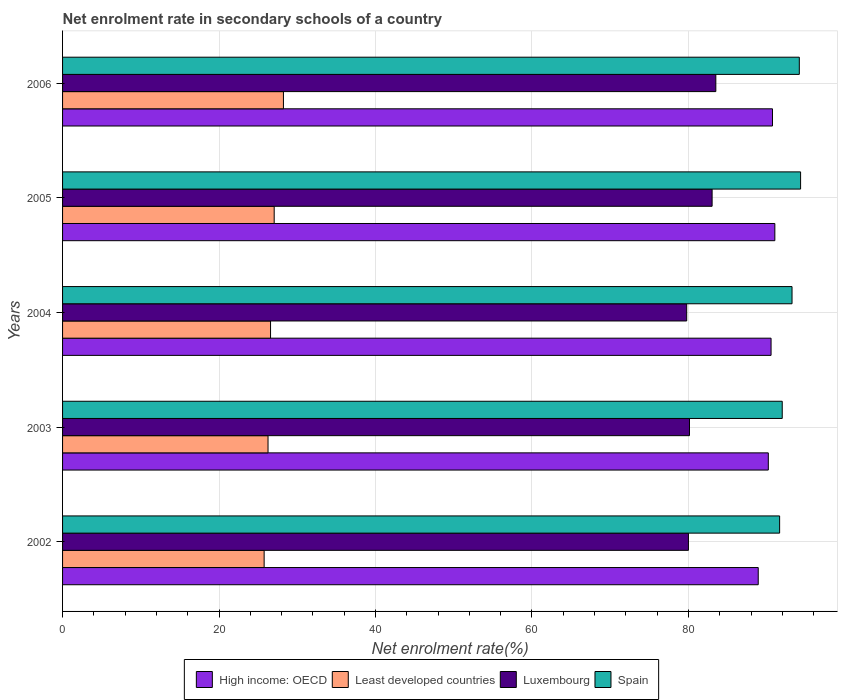How many different coloured bars are there?
Your response must be concise. 4. In how many cases, is the number of bars for a given year not equal to the number of legend labels?
Offer a very short reply. 0. What is the net enrolment rate in secondary schools in Least developed countries in 2006?
Offer a very short reply. 28.23. Across all years, what is the maximum net enrolment rate in secondary schools in Spain?
Offer a very short reply. 94.33. Across all years, what is the minimum net enrolment rate in secondary schools in Least developed countries?
Your response must be concise. 25.77. In which year was the net enrolment rate in secondary schools in Spain maximum?
Offer a terse response. 2005. What is the total net enrolment rate in secondary schools in Spain in the graph?
Your response must be concise. 465.39. What is the difference between the net enrolment rate in secondary schools in Luxembourg in 2002 and that in 2004?
Offer a terse response. 0.22. What is the difference between the net enrolment rate in secondary schools in High income: OECD in 2006 and the net enrolment rate in secondary schools in Spain in 2003?
Offer a very short reply. -1.24. What is the average net enrolment rate in secondary schools in Least developed countries per year?
Offer a terse response. 26.78. In the year 2004, what is the difference between the net enrolment rate in secondary schools in Spain and net enrolment rate in secondary schools in Luxembourg?
Ensure brevity in your answer.  13.46. What is the ratio of the net enrolment rate in secondary schools in Least developed countries in 2002 to that in 2006?
Offer a terse response. 0.91. Is the net enrolment rate in secondary schools in Luxembourg in 2003 less than that in 2005?
Your response must be concise. Yes. Is the difference between the net enrolment rate in secondary schools in Spain in 2002 and 2005 greater than the difference between the net enrolment rate in secondary schools in Luxembourg in 2002 and 2005?
Offer a terse response. Yes. What is the difference between the highest and the second highest net enrolment rate in secondary schools in Least developed countries?
Keep it short and to the point. 1.18. What is the difference between the highest and the lowest net enrolment rate in secondary schools in High income: OECD?
Provide a short and direct response. 2.12. What does the 2nd bar from the top in 2002 represents?
Give a very brief answer. Luxembourg. What does the 2nd bar from the bottom in 2005 represents?
Offer a terse response. Least developed countries. What is the difference between two consecutive major ticks on the X-axis?
Your answer should be compact. 20. Are the values on the major ticks of X-axis written in scientific E-notation?
Keep it short and to the point. No. Does the graph contain grids?
Your answer should be compact. Yes. How are the legend labels stacked?
Provide a short and direct response. Horizontal. What is the title of the graph?
Keep it short and to the point. Net enrolment rate in secondary schools of a country. What is the label or title of the X-axis?
Your answer should be very brief. Net enrolment rate(%). What is the Net enrolment rate(%) of High income: OECD in 2002?
Provide a short and direct response. 88.92. What is the Net enrolment rate(%) in Least developed countries in 2002?
Provide a short and direct response. 25.77. What is the Net enrolment rate(%) in Luxembourg in 2002?
Give a very brief answer. 80. What is the Net enrolment rate(%) of Spain in 2002?
Ensure brevity in your answer.  91.65. What is the Net enrolment rate(%) in High income: OECD in 2003?
Provide a succinct answer. 90.21. What is the Net enrolment rate(%) in Least developed countries in 2003?
Offer a terse response. 26.26. What is the Net enrolment rate(%) in Luxembourg in 2003?
Provide a succinct answer. 80.13. What is the Net enrolment rate(%) in Spain in 2003?
Provide a short and direct response. 91.99. What is the Net enrolment rate(%) of High income: OECD in 2004?
Your answer should be very brief. 90.56. What is the Net enrolment rate(%) in Least developed countries in 2004?
Your answer should be very brief. 26.58. What is the Net enrolment rate(%) of Luxembourg in 2004?
Offer a very short reply. 79.78. What is the Net enrolment rate(%) in Spain in 2004?
Make the answer very short. 93.24. What is the Net enrolment rate(%) in High income: OECD in 2005?
Offer a very short reply. 91.04. What is the Net enrolment rate(%) of Least developed countries in 2005?
Give a very brief answer. 27.05. What is the Net enrolment rate(%) in Luxembourg in 2005?
Provide a succinct answer. 83.03. What is the Net enrolment rate(%) of Spain in 2005?
Your answer should be compact. 94.33. What is the Net enrolment rate(%) in High income: OECD in 2006?
Ensure brevity in your answer.  90.74. What is the Net enrolment rate(%) in Least developed countries in 2006?
Your answer should be compact. 28.23. What is the Net enrolment rate(%) in Luxembourg in 2006?
Your answer should be very brief. 83.5. What is the Net enrolment rate(%) of Spain in 2006?
Ensure brevity in your answer.  94.17. Across all years, what is the maximum Net enrolment rate(%) of High income: OECD?
Offer a very short reply. 91.04. Across all years, what is the maximum Net enrolment rate(%) in Least developed countries?
Make the answer very short. 28.23. Across all years, what is the maximum Net enrolment rate(%) of Luxembourg?
Your answer should be very brief. 83.5. Across all years, what is the maximum Net enrolment rate(%) in Spain?
Provide a short and direct response. 94.33. Across all years, what is the minimum Net enrolment rate(%) of High income: OECD?
Give a very brief answer. 88.92. Across all years, what is the minimum Net enrolment rate(%) in Least developed countries?
Give a very brief answer. 25.77. Across all years, what is the minimum Net enrolment rate(%) of Luxembourg?
Keep it short and to the point. 79.78. Across all years, what is the minimum Net enrolment rate(%) in Spain?
Give a very brief answer. 91.65. What is the total Net enrolment rate(%) in High income: OECD in the graph?
Your answer should be very brief. 451.48. What is the total Net enrolment rate(%) of Least developed countries in the graph?
Your answer should be compact. 133.89. What is the total Net enrolment rate(%) of Luxembourg in the graph?
Offer a very short reply. 406.44. What is the total Net enrolment rate(%) of Spain in the graph?
Your answer should be compact. 465.39. What is the difference between the Net enrolment rate(%) in High income: OECD in 2002 and that in 2003?
Your response must be concise. -1.29. What is the difference between the Net enrolment rate(%) of Least developed countries in 2002 and that in 2003?
Your answer should be compact. -0.5. What is the difference between the Net enrolment rate(%) in Luxembourg in 2002 and that in 2003?
Ensure brevity in your answer.  -0.14. What is the difference between the Net enrolment rate(%) of Spain in 2002 and that in 2003?
Make the answer very short. -0.33. What is the difference between the Net enrolment rate(%) of High income: OECD in 2002 and that in 2004?
Offer a terse response. -1.64. What is the difference between the Net enrolment rate(%) of Least developed countries in 2002 and that in 2004?
Your response must be concise. -0.82. What is the difference between the Net enrolment rate(%) in Luxembourg in 2002 and that in 2004?
Offer a terse response. 0.22. What is the difference between the Net enrolment rate(%) of Spain in 2002 and that in 2004?
Your answer should be compact. -1.59. What is the difference between the Net enrolment rate(%) in High income: OECD in 2002 and that in 2005?
Your answer should be very brief. -2.12. What is the difference between the Net enrolment rate(%) in Least developed countries in 2002 and that in 2005?
Make the answer very short. -1.28. What is the difference between the Net enrolment rate(%) in Luxembourg in 2002 and that in 2005?
Your response must be concise. -3.03. What is the difference between the Net enrolment rate(%) in Spain in 2002 and that in 2005?
Provide a short and direct response. -2.68. What is the difference between the Net enrolment rate(%) of High income: OECD in 2002 and that in 2006?
Give a very brief answer. -1.82. What is the difference between the Net enrolment rate(%) of Least developed countries in 2002 and that in 2006?
Offer a very short reply. -2.47. What is the difference between the Net enrolment rate(%) in Luxembourg in 2002 and that in 2006?
Offer a very short reply. -3.5. What is the difference between the Net enrolment rate(%) in Spain in 2002 and that in 2006?
Provide a succinct answer. -2.52. What is the difference between the Net enrolment rate(%) of High income: OECD in 2003 and that in 2004?
Offer a very short reply. -0.35. What is the difference between the Net enrolment rate(%) of Least developed countries in 2003 and that in 2004?
Make the answer very short. -0.32. What is the difference between the Net enrolment rate(%) of Luxembourg in 2003 and that in 2004?
Ensure brevity in your answer.  0.36. What is the difference between the Net enrolment rate(%) of Spain in 2003 and that in 2004?
Provide a short and direct response. -1.25. What is the difference between the Net enrolment rate(%) of High income: OECD in 2003 and that in 2005?
Offer a very short reply. -0.83. What is the difference between the Net enrolment rate(%) of Least developed countries in 2003 and that in 2005?
Your answer should be very brief. -0.79. What is the difference between the Net enrolment rate(%) in Luxembourg in 2003 and that in 2005?
Provide a succinct answer. -2.89. What is the difference between the Net enrolment rate(%) of Spain in 2003 and that in 2005?
Offer a very short reply. -2.35. What is the difference between the Net enrolment rate(%) of High income: OECD in 2003 and that in 2006?
Your answer should be compact. -0.53. What is the difference between the Net enrolment rate(%) of Least developed countries in 2003 and that in 2006?
Make the answer very short. -1.97. What is the difference between the Net enrolment rate(%) in Luxembourg in 2003 and that in 2006?
Give a very brief answer. -3.37. What is the difference between the Net enrolment rate(%) of Spain in 2003 and that in 2006?
Your answer should be compact. -2.18. What is the difference between the Net enrolment rate(%) of High income: OECD in 2004 and that in 2005?
Provide a succinct answer. -0.48. What is the difference between the Net enrolment rate(%) of Least developed countries in 2004 and that in 2005?
Your response must be concise. -0.46. What is the difference between the Net enrolment rate(%) in Luxembourg in 2004 and that in 2005?
Make the answer very short. -3.25. What is the difference between the Net enrolment rate(%) of Spain in 2004 and that in 2005?
Keep it short and to the point. -1.09. What is the difference between the Net enrolment rate(%) in High income: OECD in 2004 and that in 2006?
Offer a very short reply. -0.18. What is the difference between the Net enrolment rate(%) in Least developed countries in 2004 and that in 2006?
Your answer should be compact. -1.65. What is the difference between the Net enrolment rate(%) of Luxembourg in 2004 and that in 2006?
Your answer should be compact. -3.72. What is the difference between the Net enrolment rate(%) in Spain in 2004 and that in 2006?
Provide a short and direct response. -0.93. What is the difference between the Net enrolment rate(%) in High income: OECD in 2005 and that in 2006?
Offer a very short reply. 0.3. What is the difference between the Net enrolment rate(%) in Least developed countries in 2005 and that in 2006?
Make the answer very short. -1.18. What is the difference between the Net enrolment rate(%) of Luxembourg in 2005 and that in 2006?
Give a very brief answer. -0.47. What is the difference between the Net enrolment rate(%) of Spain in 2005 and that in 2006?
Ensure brevity in your answer.  0.16. What is the difference between the Net enrolment rate(%) in High income: OECD in 2002 and the Net enrolment rate(%) in Least developed countries in 2003?
Your answer should be compact. 62.66. What is the difference between the Net enrolment rate(%) of High income: OECD in 2002 and the Net enrolment rate(%) of Luxembourg in 2003?
Give a very brief answer. 8.79. What is the difference between the Net enrolment rate(%) of High income: OECD in 2002 and the Net enrolment rate(%) of Spain in 2003?
Your response must be concise. -3.07. What is the difference between the Net enrolment rate(%) in Least developed countries in 2002 and the Net enrolment rate(%) in Luxembourg in 2003?
Give a very brief answer. -54.37. What is the difference between the Net enrolment rate(%) of Least developed countries in 2002 and the Net enrolment rate(%) of Spain in 2003?
Make the answer very short. -66.22. What is the difference between the Net enrolment rate(%) in Luxembourg in 2002 and the Net enrolment rate(%) in Spain in 2003?
Keep it short and to the point. -11.99. What is the difference between the Net enrolment rate(%) in High income: OECD in 2002 and the Net enrolment rate(%) in Least developed countries in 2004?
Keep it short and to the point. 62.34. What is the difference between the Net enrolment rate(%) in High income: OECD in 2002 and the Net enrolment rate(%) in Luxembourg in 2004?
Offer a terse response. 9.14. What is the difference between the Net enrolment rate(%) in High income: OECD in 2002 and the Net enrolment rate(%) in Spain in 2004?
Your answer should be very brief. -4.32. What is the difference between the Net enrolment rate(%) of Least developed countries in 2002 and the Net enrolment rate(%) of Luxembourg in 2004?
Offer a terse response. -54.01. What is the difference between the Net enrolment rate(%) of Least developed countries in 2002 and the Net enrolment rate(%) of Spain in 2004?
Your answer should be compact. -67.48. What is the difference between the Net enrolment rate(%) in Luxembourg in 2002 and the Net enrolment rate(%) in Spain in 2004?
Provide a short and direct response. -13.24. What is the difference between the Net enrolment rate(%) of High income: OECD in 2002 and the Net enrolment rate(%) of Least developed countries in 2005?
Make the answer very short. 61.87. What is the difference between the Net enrolment rate(%) in High income: OECD in 2002 and the Net enrolment rate(%) in Luxembourg in 2005?
Provide a succinct answer. 5.9. What is the difference between the Net enrolment rate(%) of High income: OECD in 2002 and the Net enrolment rate(%) of Spain in 2005?
Your response must be concise. -5.41. What is the difference between the Net enrolment rate(%) of Least developed countries in 2002 and the Net enrolment rate(%) of Luxembourg in 2005?
Provide a short and direct response. -57.26. What is the difference between the Net enrolment rate(%) of Least developed countries in 2002 and the Net enrolment rate(%) of Spain in 2005?
Provide a succinct answer. -68.57. What is the difference between the Net enrolment rate(%) of Luxembourg in 2002 and the Net enrolment rate(%) of Spain in 2005?
Your response must be concise. -14.34. What is the difference between the Net enrolment rate(%) in High income: OECD in 2002 and the Net enrolment rate(%) in Least developed countries in 2006?
Provide a short and direct response. 60.69. What is the difference between the Net enrolment rate(%) in High income: OECD in 2002 and the Net enrolment rate(%) in Luxembourg in 2006?
Your answer should be compact. 5.42. What is the difference between the Net enrolment rate(%) in High income: OECD in 2002 and the Net enrolment rate(%) in Spain in 2006?
Provide a short and direct response. -5.25. What is the difference between the Net enrolment rate(%) in Least developed countries in 2002 and the Net enrolment rate(%) in Luxembourg in 2006?
Your response must be concise. -57.73. What is the difference between the Net enrolment rate(%) in Least developed countries in 2002 and the Net enrolment rate(%) in Spain in 2006?
Give a very brief answer. -68.41. What is the difference between the Net enrolment rate(%) in Luxembourg in 2002 and the Net enrolment rate(%) in Spain in 2006?
Offer a very short reply. -14.17. What is the difference between the Net enrolment rate(%) of High income: OECD in 2003 and the Net enrolment rate(%) of Least developed countries in 2004?
Your answer should be compact. 63.63. What is the difference between the Net enrolment rate(%) in High income: OECD in 2003 and the Net enrolment rate(%) in Luxembourg in 2004?
Keep it short and to the point. 10.43. What is the difference between the Net enrolment rate(%) in High income: OECD in 2003 and the Net enrolment rate(%) in Spain in 2004?
Your answer should be very brief. -3.03. What is the difference between the Net enrolment rate(%) in Least developed countries in 2003 and the Net enrolment rate(%) in Luxembourg in 2004?
Provide a short and direct response. -53.52. What is the difference between the Net enrolment rate(%) of Least developed countries in 2003 and the Net enrolment rate(%) of Spain in 2004?
Your answer should be very brief. -66.98. What is the difference between the Net enrolment rate(%) in Luxembourg in 2003 and the Net enrolment rate(%) in Spain in 2004?
Offer a terse response. -13.11. What is the difference between the Net enrolment rate(%) in High income: OECD in 2003 and the Net enrolment rate(%) in Least developed countries in 2005?
Give a very brief answer. 63.16. What is the difference between the Net enrolment rate(%) in High income: OECD in 2003 and the Net enrolment rate(%) in Luxembourg in 2005?
Ensure brevity in your answer.  7.18. What is the difference between the Net enrolment rate(%) of High income: OECD in 2003 and the Net enrolment rate(%) of Spain in 2005?
Offer a very short reply. -4.13. What is the difference between the Net enrolment rate(%) in Least developed countries in 2003 and the Net enrolment rate(%) in Luxembourg in 2005?
Your answer should be compact. -56.76. What is the difference between the Net enrolment rate(%) of Least developed countries in 2003 and the Net enrolment rate(%) of Spain in 2005?
Your answer should be very brief. -68.07. What is the difference between the Net enrolment rate(%) in Luxembourg in 2003 and the Net enrolment rate(%) in Spain in 2005?
Your answer should be very brief. -14.2. What is the difference between the Net enrolment rate(%) of High income: OECD in 2003 and the Net enrolment rate(%) of Least developed countries in 2006?
Make the answer very short. 61.98. What is the difference between the Net enrolment rate(%) in High income: OECD in 2003 and the Net enrolment rate(%) in Luxembourg in 2006?
Your answer should be very brief. 6.71. What is the difference between the Net enrolment rate(%) in High income: OECD in 2003 and the Net enrolment rate(%) in Spain in 2006?
Provide a succinct answer. -3.96. What is the difference between the Net enrolment rate(%) in Least developed countries in 2003 and the Net enrolment rate(%) in Luxembourg in 2006?
Your response must be concise. -57.24. What is the difference between the Net enrolment rate(%) in Least developed countries in 2003 and the Net enrolment rate(%) in Spain in 2006?
Your response must be concise. -67.91. What is the difference between the Net enrolment rate(%) in Luxembourg in 2003 and the Net enrolment rate(%) in Spain in 2006?
Offer a very short reply. -14.04. What is the difference between the Net enrolment rate(%) of High income: OECD in 2004 and the Net enrolment rate(%) of Least developed countries in 2005?
Provide a short and direct response. 63.51. What is the difference between the Net enrolment rate(%) in High income: OECD in 2004 and the Net enrolment rate(%) in Luxembourg in 2005?
Offer a very short reply. 7.54. What is the difference between the Net enrolment rate(%) in High income: OECD in 2004 and the Net enrolment rate(%) in Spain in 2005?
Make the answer very short. -3.77. What is the difference between the Net enrolment rate(%) of Least developed countries in 2004 and the Net enrolment rate(%) of Luxembourg in 2005?
Keep it short and to the point. -56.44. What is the difference between the Net enrolment rate(%) in Least developed countries in 2004 and the Net enrolment rate(%) in Spain in 2005?
Your response must be concise. -67.75. What is the difference between the Net enrolment rate(%) of Luxembourg in 2004 and the Net enrolment rate(%) of Spain in 2005?
Give a very brief answer. -14.56. What is the difference between the Net enrolment rate(%) of High income: OECD in 2004 and the Net enrolment rate(%) of Least developed countries in 2006?
Your answer should be compact. 62.33. What is the difference between the Net enrolment rate(%) in High income: OECD in 2004 and the Net enrolment rate(%) in Luxembourg in 2006?
Your answer should be compact. 7.06. What is the difference between the Net enrolment rate(%) in High income: OECD in 2004 and the Net enrolment rate(%) in Spain in 2006?
Your answer should be compact. -3.61. What is the difference between the Net enrolment rate(%) of Least developed countries in 2004 and the Net enrolment rate(%) of Luxembourg in 2006?
Offer a terse response. -56.92. What is the difference between the Net enrolment rate(%) in Least developed countries in 2004 and the Net enrolment rate(%) in Spain in 2006?
Provide a succinct answer. -67.59. What is the difference between the Net enrolment rate(%) in Luxembourg in 2004 and the Net enrolment rate(%) in Spain in 2006?
Ensure brevity in your answer.  -14.39. What is the difference between the Net enrolment rate(%) of High income: OECD in 2005 and the Net enrolment rate(%) of Least developed countries in 2006?
Give a very brief answer. 62.81. What is the difference between the Net enrolment rate(%) of High income: OECD in 2005 and the Net enrolment rate(%) of Luxembourg in 2006?
Keep it short and to the point. 7.54. What is the difference between the Net enrolment rate(%) in High income: OECD in 2005 and the Net enrolment rate(%) in Spain in 2006?
Keep it short and to the point. -3.13. What is the difference between the Net enrolment rate(%) in Least developed countries in 2005 and the Net enrolment rate(%) in Luxembourg in 2006?
Keep it short and to the point. -56.45. What is the difference between the Net enrolment rate(%) in Least developed countries in 2005 and the Net enrolment rate(%) in Spain in 2006?
Ensure brevity in your answer.  -67.12. What is the difference between the Net enrolment rate(%) in Luxembourg in 2005 and the Net enrolment rate(%) in Spain in 2006?
Your response must be concise. -11.15. What is the average Net enrolment rate(%) in High income: OECD per year?
Offer a terse response. 90.3. What is the average Net enrolment rate(%) in Least developed countries per year?
Keep it short and to the point. 26.78. What is the average Net enrolment rate(%) of Luxembourg per year?
Offer a very short reply. 81.29. What is the average Net enrolment rate(%) of Spain per year?
Ensure brevity in your answer.  93.08. In the year 2002, what is the difference between the Net enrolment rate(%) in High income: OECD and Net enrolment rate(%) in Least developed countries?
Keep it short and to the point. 63.16. In the year 2002, what is the difference between the Net enrolment rate(%) in High income: OECD and Net enrolment rate(%) in Luxembourg?
Ensure brevity in your answer.  8.92. In the year 2002, what is the difference between the Net enrolment rate(%) of High income: OECD and Net enrolment rate(%) of Spain?
Give a very brief answer. -2.73. In the year 2002, what is the difference between the Net enrolment rate(%) of Least developed countries and Net enrolment rate(%) of Luxembourg?
Your response must be concise. -54.23. In the year 2002, what is the difference between the Net enrolment rate(%) of Least developed countries and Net enrolment rate(%) of Spain?
Your response must be concise. -65.89. In the year 2002, what is the difference between the Net enrolment rate(%) of Luxembourg and Net enrolment rate(%) of Spain?
Give a very brief answer. -11.66. In the year 2003, what is the difference between the Net enrolment rate(%) in High income: OECD and Net enrolment rate(%) in Least developed countries?
Make the answer very short. 63.95. In the year 2003, what is the difference between the Net enrolment rate(%) in High income: OECD and Net enrolment rate(%) in Luxembourg?
Your answer should be compact. 10.08. In the year 2003, what is the difference between the Net enrolment rate(%) in High income: OECD and Net enrolment rate(%) in Spain?
Provide a succinct answer. -1.78. In the year 2003, what is the difference between the Net enrolment rate(%) in Least developed countries and Net enrolment rate(%) in Luxembourg?
Your answer should be compact. -53.87. In the year 2003, what is the difference between the Net enrolment rate(%) of Least developed countries and Net enrolment rate(%) of Spain?
Provide a short and direct response. -65.73. In the year 2003, what is the difference between the Net enrolment rate(%) of Luxembourg and Net enrolment rate(%) of Spain?
Provide a succinct answer. -11.85. In the year 2004, what is the difference between the Net enrolment rate(%) of High income: OECD and Net enrolment rate(%) of Least developed countries?
Give a very brief answer. 63.98. In the year 2004, what is the difference between the Net enrolment rate(%) in High income: OECD and Net enrolment rate(%) in Luxembourg?
Keep it short and to the point. 10.78. In the year 2004, what is the difference between the Net enrolment rate(%) of High income: OECD and Net enrolment rate(%) of Spain?
Make the answer very short. -2.68. In the year 2004, what is the difference between the Net enrolment rate(%) in Least developed countries and Net enrolment rate(%) in Luxembourg?
Your answer should be compact. -53.19. In the year 2004, what is the difference between the Net enrolment rate(%) in Least developed countries and Net enrolment rate(%) in Spain?
Give a very brief answer. -66.66. In the year 2004, what is the difference between the Net enrolment rate(%) of Luxembourg and Net enrolment rate(%) of Spain?
Offer a very short reply. -13.46. In the year 2005, what is the difference between the Net enrolment rate(%) of High income: OECD and Net enrolment rate(%) of Least developed countries?
Make the answer very short. 63.99. In the year 2005, what is the difference between the Net enrolment rate(%) of High income: OECD and Net enrolment rate(%) of Luxembourg?
Ensure brevity in your answer.  8.02. In the year 2005, what is the difference between the Net enrolment rate(%) in High income: OECD and Net enrolment rate(%) in Spain?
Ensure brevity in your answer.  -3.29. In the year 2005, what is the difference between the Net enrolment rate(%) of Least developed countries and Net enrolment rate(%) of Luxembourg?
Offer a very short reply. -55.98. In the year 2005, what is the difference between the Net enrolment rate(%) in Least developed countries and Net enrolment rate(%) in Spain?
Offer a very short reply. -67.29. In the year 2005, what is the difference between the Net enrolment rate(%) in Luxembourg and Net enrolment rate(%) in Spain?
Ensure brevity in your answer.  -11.31. In the year 2006, what is the difference between the Net enrolment rate(%) in High income: OECD and Net enrolment rate(%) in Least developed countries?
Ensure brevity in your answer.  62.51. In the year 2006, what is the difference between the Net enrolment rate(%) in High income: OECD and Net enrolment rate(%) in Luxembourg?
Make the answer very short. 7.24. In the year 2006, what is the difference between the Net enrolment rate(%) of High income: OECD and Net enrolment rate(%) of Spain?
Your answer should be compact. -3.43. In the year 2006, what is the difference between the Net enrolment rate(%) of Least developed countries and Net enrolment rate(%) of Luxembourg?
Offer a very short reply. -55.27. In the year 2006, what is the difference between the Net enrolment rate(%) of Least developed countries and Net enrolment rate(%) of Spain?
Offer a very short reply. -65.94. In the year 2006, what is the difference between the Net enrolment rate(%) in Luxembourg and Net enrolment rate(%) in Spain?
Your answer should be very brief. -10.67. What is the ratio of the Net enrolment rate(%) of High income: OECD in 2002 to that in 2003?
Your response must be concise. 0.99. What is the ratio of the Net enrolment rate(%) in Least developed countries in 2002 to that in 2003?
Make the answer very short. 0.98. What is the ratio of the Net enrolment rate(%) of Luxembourg in 2002 to that in 2003?
Your answer should be compact. 1. What is the ratio of the Net enrolment rate(%) of High income: OECD in 2002 to that in 2004?
Offer a very short reply. 0.98. What is the ratio of the Net enrolment rate(%) in Least developed countries in 2002 to that in 2004?
Your response must be concise. 0.97. What is the ratio of the Net enrolment rate(%) of Luxembourg in 2002 to that in 2004?
Your answer should be very brief. 1. What is the ratio of the Net enrolment rate(%) of Spain in 2002 to that in 2004?
Offer a very short reply. 0.98. What is the ratio of the Net enrolment rate(%) of High income: OECD in 2002 to that in 2005?
Your answer should be very brief. 0.98. What is the ratio of the Net enrolment rate(%) in Least developed countries in 2002 to that in 2005?
Offer a very short reply. 0.95. What is the ratio of the Net enrolment rate(%) in Luxembourg in 2002 to that in 2005?
Provide a short and direct response. 0.96. What is the ratio of the Net enrolment rate(%) in Spain in 2002 to that in 2005?
Ensure brevity in your answer.  0.97. What is the ratio of the Net enrolment rate(%) of High income: OECD in 2002 to that in 2006?
Your answer should be very brief. 0.98. What is the ratio of the Net enrolment rate(%) of Least developed countries in 2002 to that in 2006?
Your response must be concise. 0.91. What is the ratio of the Net enrolment rate(%) of Luxembourg in 2002 to that in 2006?
Give a very brief answer. 0.96. What is the ratio of the Net enrolment rate(%) of Spain in 2002 to that in 2006?
Your response must be concise. 0.97. What is the ratio of the Net enrolment rate(%) in High income: OECD in 2003 to that in 2004?
Your answer should be compact. 1. What is the ratio of the Net enrolment rate(%) of Least developed countries in 2003 to that in 2004?
Give a very brief answer. 0.99. What is the ratio of the Net enrolment rate(%) of Luxembourg in 2003 to that in 2004?
Offer a terse response. 1. What is the ratio of the Net enrolment rate(%) in Spain in 2003 to that in 2004?
Provide a short and direct response. 0.99. What is the ratio of the Net enrolment rate(%) of High income: OECD in 2003 to that in 2005?
Provide a short and direct response. 0.99. What is the ratio of the Net enrolment rate(%) of Least developed countries in 2003 to that in 2005?
Make the answer very short. 0.97. What is the ratio of the Net enrolment rate(%) in Luxembourg in 2003 to that in 2005?
Make the answer very short. 0.97. What is the ratio of the Net enrolment rate(%) in Spain in 2003 to that in 2005?
Give a very brief answer. 0.98. What is the ratio of the Net enrolment rate(%) in High income: OECD in 2003 to that in 2006?
Keep it short and to the point. 0.99. What is the ratio of the Net enrolment rate(%) in Least developed countries in 2003 to that in 2006?
Offer a terse response. 0.93. What is the ratio of the Net enrolment rate(%) of Luxembourg in 2003 to that in 2006?
Give a very brief answer. 0.96. What is the ratio of the Net enrolment rate(%) in Spain in 2003 to that in 2006?
Offer a terse response. 0.98. What is the ratio of the Net enrolment rate(%) of High income: OECD in 2004 to that in 2005?
Keep it short and to the point. 0.99. What is the ratio of the Net enrolment rate(%) in Least developed countries in 2004 to that in 2005?
Provide a short and direct response. 0.98. What is the ratio of the Net enrolment rate(%) in Luxembourg in 2004 to that in 2005?
Your response must be concise. 0.96. What is the ratio of the Net enrolment rate(%) in Spain in 2004 to that in 2005?
Make the answer very short. 0.99. What is the ratio of the Net enrolment rate(%) of Least developed countries in 2004 to that in 2006?
Make the answer very short. 0.94. What is the ratio of the Net enrolment rate(%) of Luxembourg in 2004 to that in 2006?
Offer a very short reply. 0.96. What is the ratio of the Net enrolment rate(%) of Least developed countries in 2005 to that in 2006?
Offer a very short reply. 0.96. What is the ratio of the Net enrolment rate(%) of Luxembourg in 2005 to that in 2006?
Keep it short and to the point. 0.99. What is the ratio of the Net enrolment rate(%) in Spain in 2005 to that in 2006?
Your answer should be compact. 1. What is the difference between the highest and the second highest Net enrolment rate(%) in High income: OECD?
Give a very brief answer. 0.3. What is the difference between the highest and the second highest Net enrolment rate(%) in Least developed countries?
Offer a very short reply. 1.18. What is the difference between the highest and the second highest Net enrolment rate(%) of Luxembourg?
Ensure brevity in your answer.  0.47. What is the difference between the highest and the second highest Net enrolment rate(%) of Spain?
Give a very brief answer. 0.16. What is the difference between the highest and the lowest Net enrolment rate(%) of High income: OECD?
Provide a short and direct response. 2.12. What is the difference between the highest and the lowest Net enrolment rate(%) of Least developed countries?
Provide a succinct answer. 2.47. What is the difference between the highest and the lowest Net enrolment rate(%) of Luxembourg?
Offer a terse response. 3.72. What is the difference between the highest and the lowest Net enrolment rate(%) in Spain?
Provide a short and direct response. 2.68. 